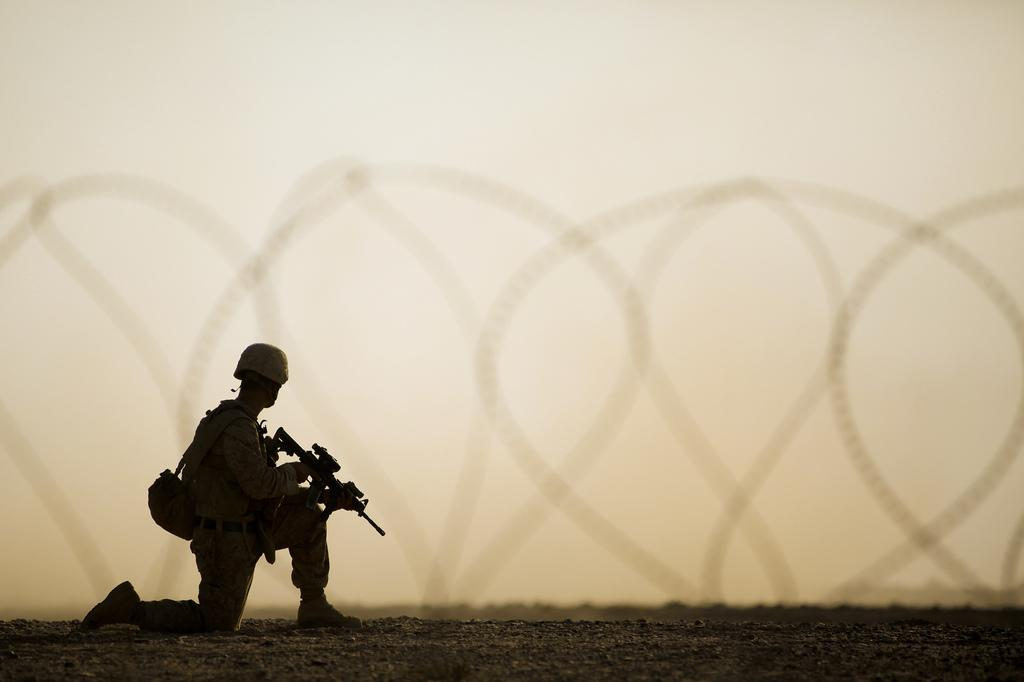What is the main subject of the image? There is a man in the image. What is the man holding in his hands? The man is holding a gun in his hands. What is the man wearing on his head? The man is wearing a helmet on his head. What else is the man carrying in the image? The man is carrying a bag. What can be seen in the background of the image? The sky is visible in the image. What type of lamp can be seen illuminating the man's face in the image? There is no lamp present in the image; the man is standing outdoors with the sky visible in the background. What kind of marble is visible on the ground in the image? There is no marble visible in the image; the ground is not described in the provided facts. 